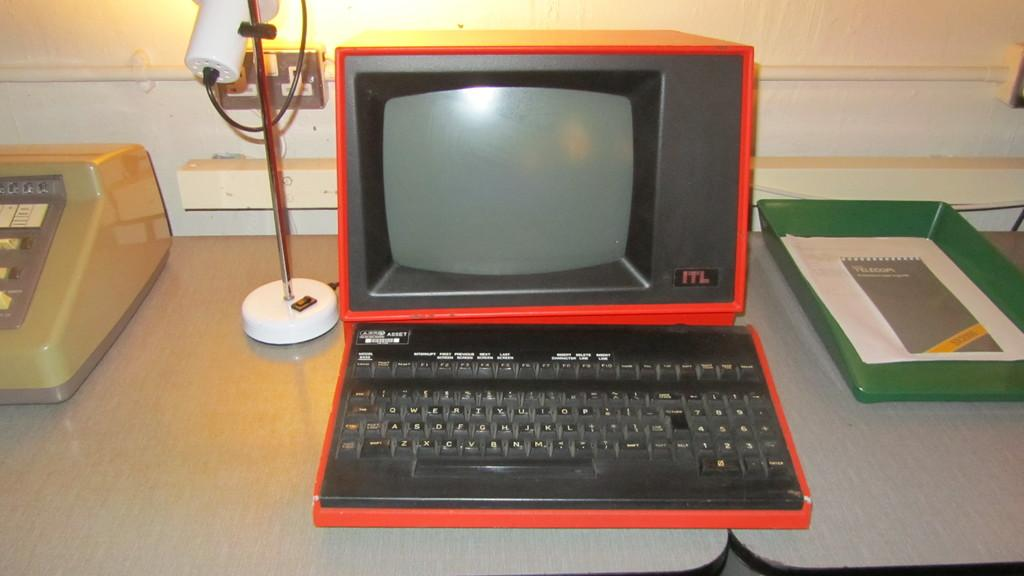Provide a one-sentence caption for the provided image. A red and black computer has ITL in the right hand corner of the monitor. 